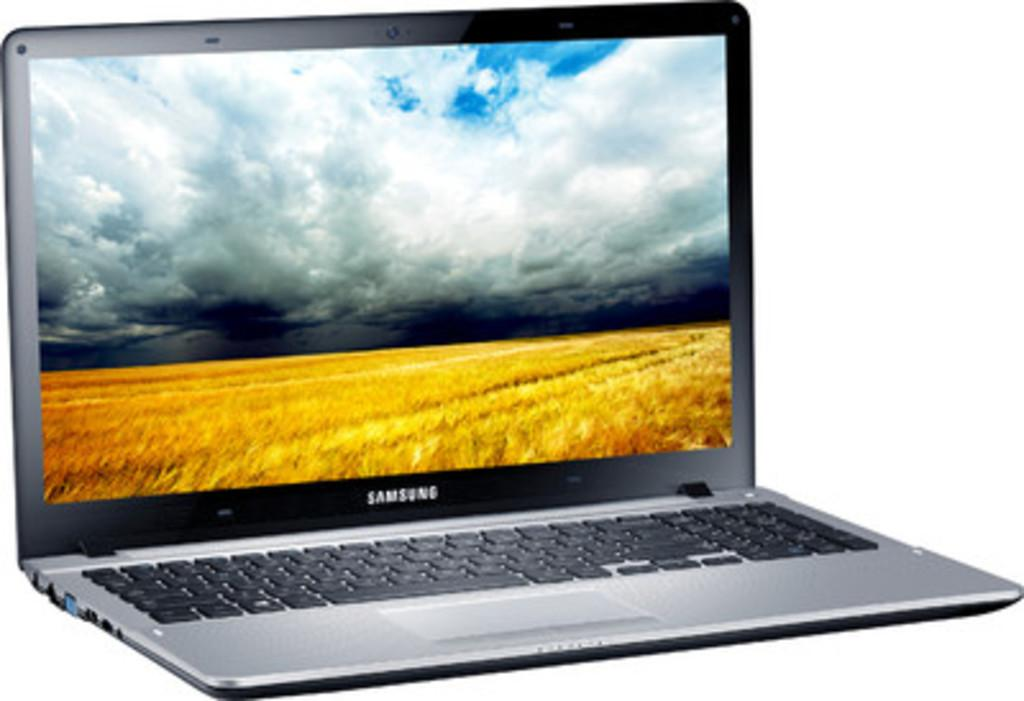<image>
Describe the image concisely. a display of a Samsung silver lap top computer 